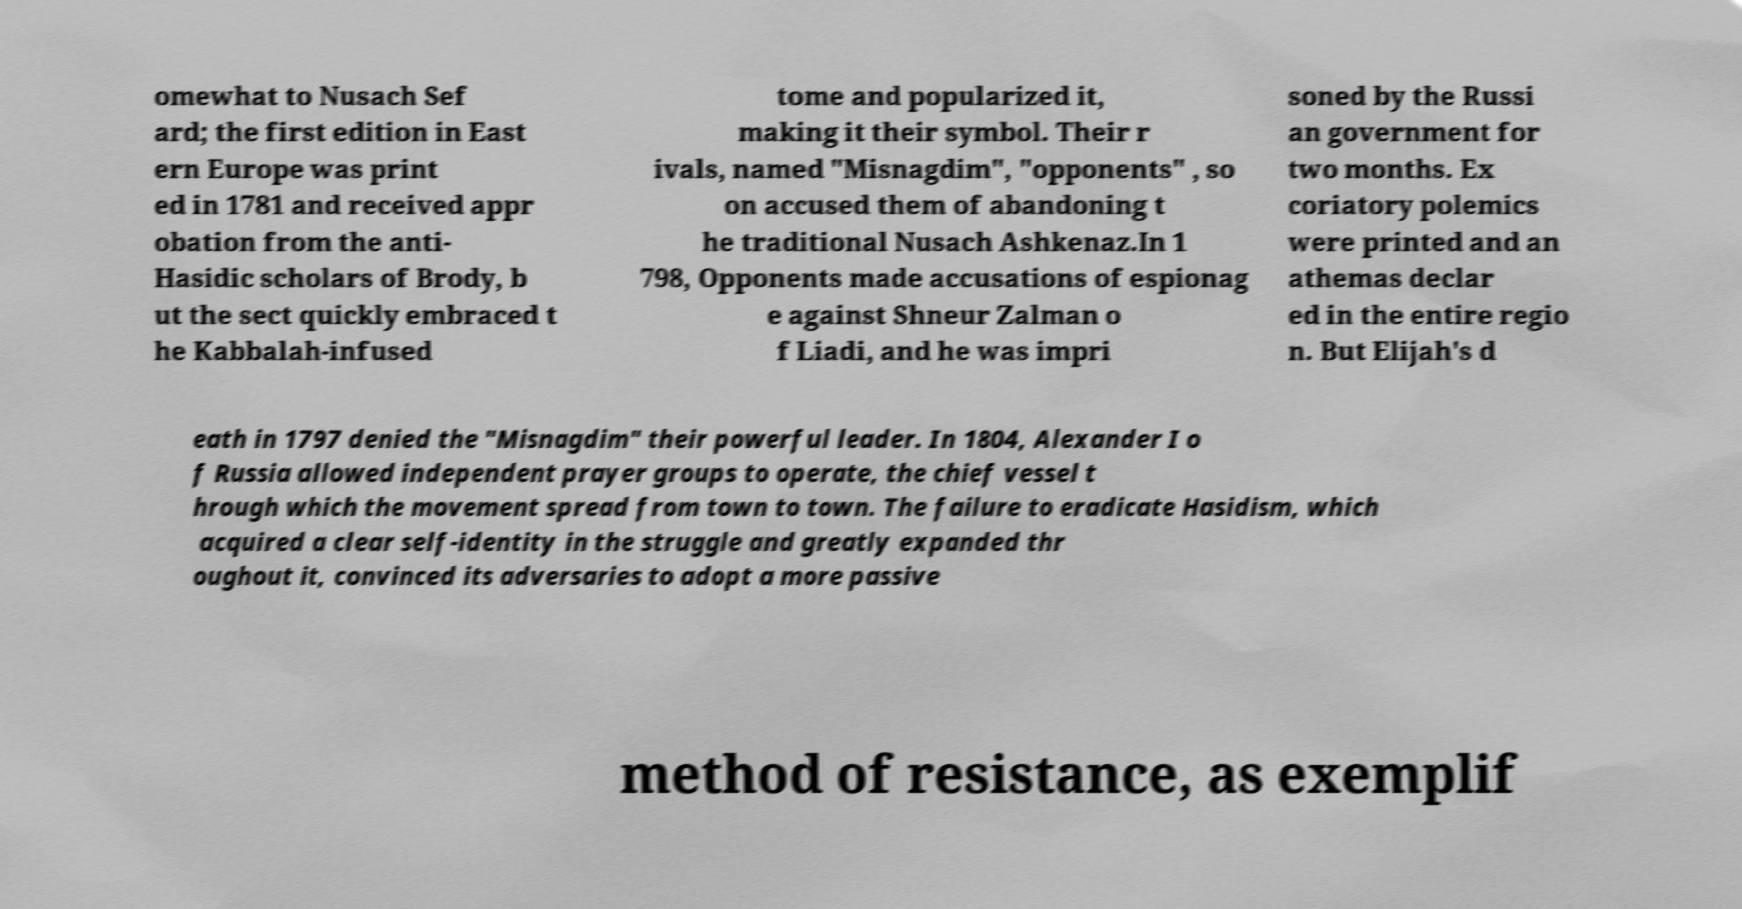Please read and relay the text visible in this image. What does it say? omewhat to Nusach Sef ard; the first edition in East ern Europe was print ed in 1781 and received appr obation from the anti- Hasidic scholars of Brody, b ut the sect quickly embraced t he Kabbalah-infused tome and popularized it, making it their symbol. Their r ivals, named "Misnagdim", "opponents" , so on accused them of abandoning t he traditional Nusach Ashkenaz.In 1 798, Opponents made accusations of espionag e against Shneur Zalman o f Liadi, and he was impri soned by the Russi an government for two months. Ex coriatory polemics were printed and an athemas declar ed in the entire regio n. But Elijah's d eath in 1797 denied the "Misnagdim" their powerful leader. In 1804, Alexander I o f Russia allowed independent prayer groups to operate, the chief vessel t hrough which the movement spread from town to town. The failure to eradicate Hasidism, which acquired a clear self-identity in the struggle and greatly expanded thr oughout it, convinced its adversaries to adopt a more passive method of resistance, as exemplif 